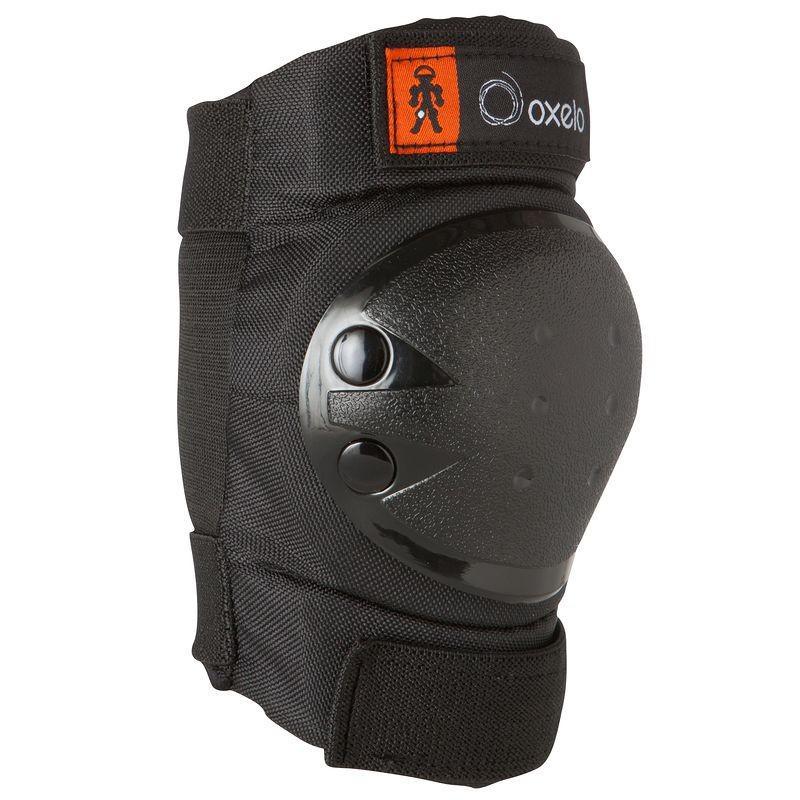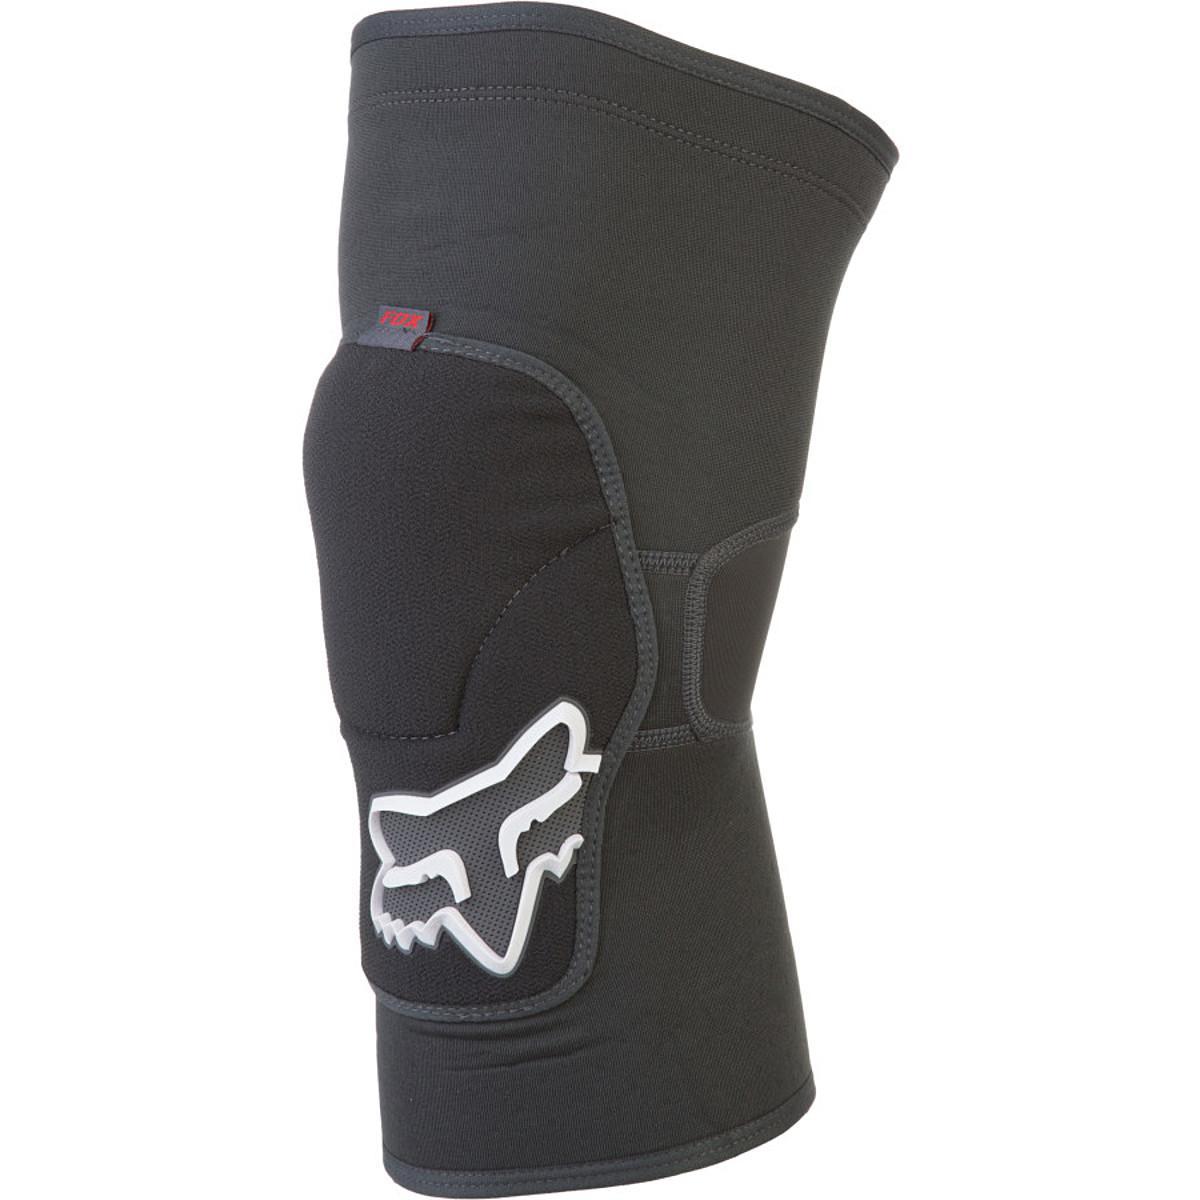The first image is the image on the left, the second image is the image on the right. For the images displayed, is the sentence "One or more of the knee pads has an """"X"""" logo" factually correct? Answer yes or no. No. 